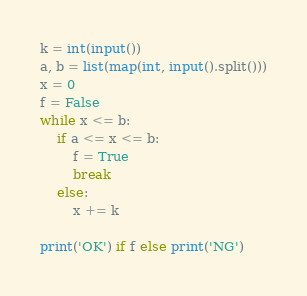<code> <loc_0><loc_0><loc_500><loc_500><_Python_>k = int(input())
a, b = list(map(int, input().split()))
x = 0
f = False
while x <= b:
    if a <= x <= b:
        f = True
        break
    else:
        x += k

print('OK') if f else print('NG')</code> 